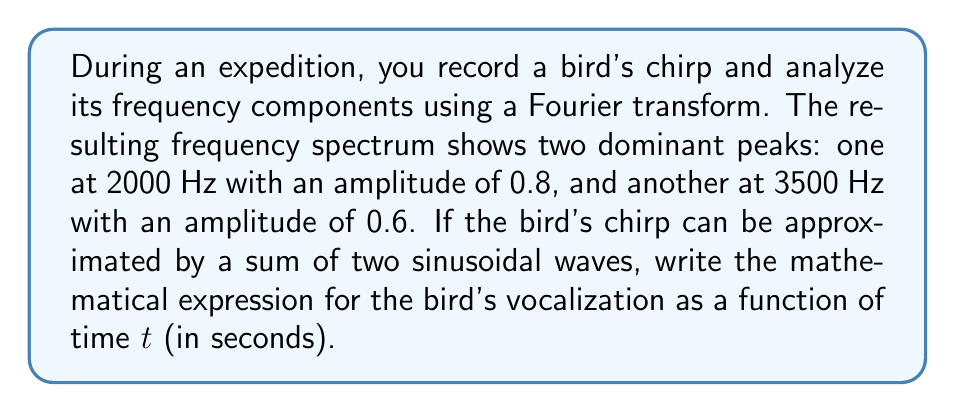What is the answer to this math problem? To solve this problem, we'll follow these steps:

1) The general form of a sinusoidal wave is:

   $A \sin(2\pi ft + \phi)$

   where $A$ is the amplitude, $f$ is the frequency, $t$ is time, and $\phi$ is the phase shift.

2) We have two frequency components:
   - $f_1 = 2000$ Hz with amplitude $A_1 = 0.8$
   - $f_2 = 3500$ Hz with amplitude $A_2 = 0.6$

3) Since we don't have information about phase shifts, we'll assume they're zero for simplicity.

4) The bird's vocalization will be the sum of these two components:

   $y(t) = A_1 \sin(2\pi f_1 t) + A_2 \sin(2\pi f_2 t)$

5) Substituting the values:

   $y(t) = 0.8 \sin(2\pi \cdot 2000 t) + 0.6 \sin(2\pi \cdot 3500 t)$

6) Simplifying:

   $y(t) = 0.8 \sin(4000\pi t) + 0.6 \sin(7000\pi t)$

This expression represents the bird's chirp as a function of time $t$ in seconds.
Answer: $y(t) = 0.8 \sin(4000\pi t) + 0.6 \sin(7000\pi t)$ 